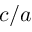<formula> <loc_0><loc_0><loc_500><loc_500>c / a</formula> 